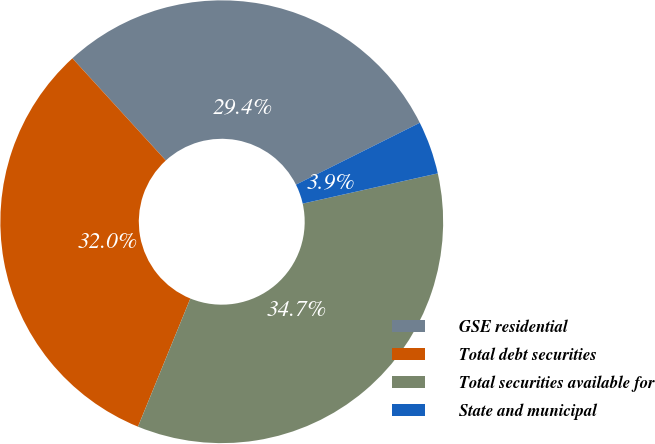Convert chart. <chart><loc_0><loc_0><loc_500><loc_500><pie_chart><fcel>GSE residential<fcel>Total debt securities<fcel>Total securities available for<fcel>State and municipal<nl><fcel>29.41%<fcel>32.04%<fcel>34.68%<fcel>3.87%<nl></chart> 